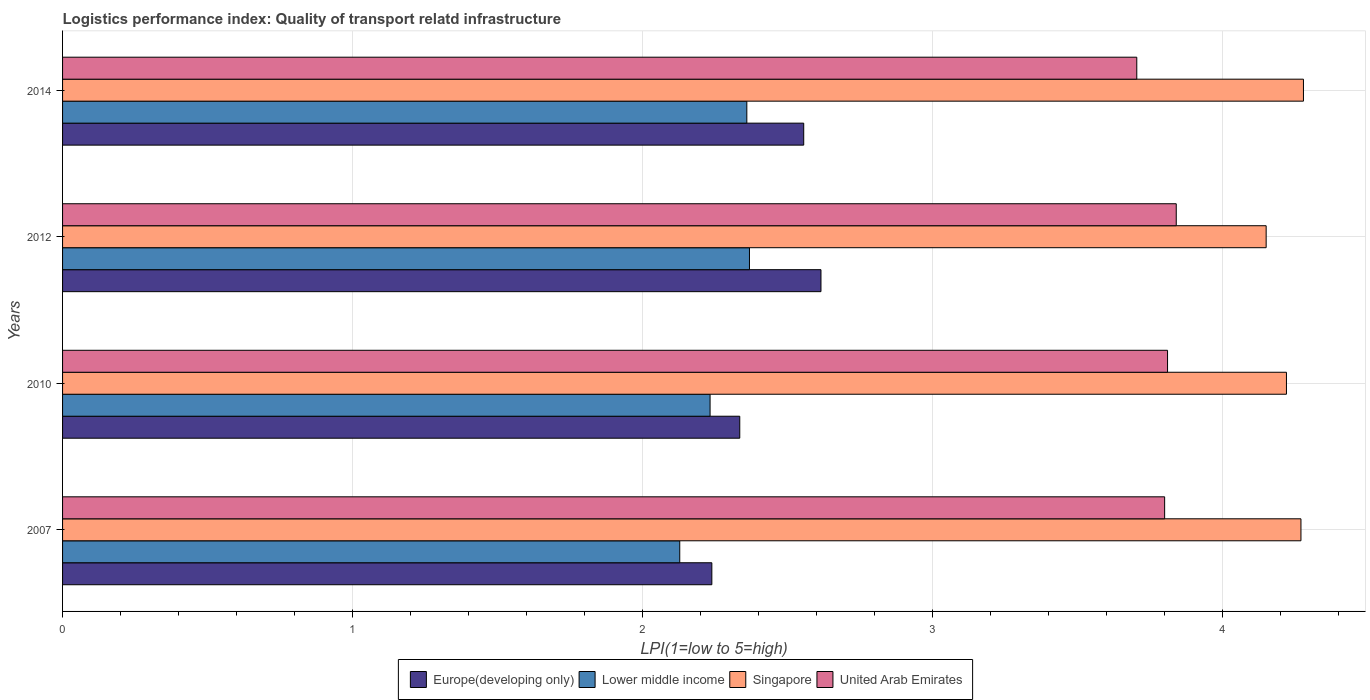How many different coloured bars are there?
Give a very brief answer. 4. How many groups of bars are there?
Keep it short and to the point. 4. Are the number of bars on each tick of the Y-axis equal?
Make the answer very short. Yes. How many bars are there on the 1st tick from the top?
Your answer should be very brief. 4. In how many cases, is the number of bars for a given year not equal to the number of legend labels?
Your answer should be very brief. 0. What is the logistics performance index in United Arab Emirates in 2014?
Your answer should be compact. 3.7. Across all years, what is the maximum logistics performance index in Lower middle income?
Ensure brevity in your answer.  2.37. Across all years, what is the minimum logistics performance index in Singapore?
Your answer should be very brief. 4.15. What is the total logistics performance index in Europe(developing only) in the graph?
Offer a very short reply. 9.74. What is the difference between the logistics performance index in United Arab Emirates in 2007 and that in 2014?
Your response must be concise. 0.1. What is the difference between the logistics performance index in Lower middle income in 2007 and the logistics performance index in Europe(developing only) in 2012?
Your answer should be very brief. -0.49. What is the average logistics performance index in Europe(developing only) per year?
Your response must be concise. 2.44. In the year 2007, what is the difference between the logistics performance index in Europe(developing only) and logistics performance index in Singapore?
Give a very brief answer. -2.03. In how many years, is the logistics performance index in United Arab Emirates greater than 4 ?
Provide a succinct answer. 0. What is the ratio of the logistics performance index in Lower middle income in 2007 to that in 2014?
Your response must be concise. 0.9. Is the logistics performance index in Lower middle income in 2010 less than that in 2014?
Your response must be concise. Yes. What is the difference between the highest and the second highest logistics performance index in Lower middle income?
Provide a succinct answer. 0.01. What is the difference between the highest and the lowest logistics performance index in Singapore?
Make the answer very short. 0.13. What does the 4th bar from the top in 2014 represents?
Your answer should be very brief. Europe(developing only). What does the 2nd bar from the bottom in 2014 represents?
Your answer should be very brief. Lower middle income. Is it the case that in every year, the sum of the logistics performance index in Europe(developing only) and logistics performance index in United Arab Emirates is greater than the logistics performance index in Lower middle income?
Give a very brief answer. Yes. Are all the bars in the graph horizontal?
Keep it short and to the point. Yes. What is the difference between two consecutive major ticks on the X-axis?
Offer a terse response. 1. Are the values on the major ticks of X-axis written in scientific E-notation?
Make the answer very short. No. Where does the legend appear in the graph?
Your answer should be compact. Bottom center. How many legend labels are there?
Your answer should be very brief. 4. What is the title of the graph?
Keep it short and to the point. Logistics performance index: Quality of transport relatd infrastructure. Does "Benin" appear as one of the legend labels in the graph?
Offer a terse response. No. What is the label or title of the X-axis?
Your answer should be very brief. LPI(1=low to 5=high). What is the label or title of the Y-axis?
Your answer should be very brief. Years. What is the LPI(1=low to 5=high) in Europe(developing only) in 2007?
Offer a very short reply. 2.24. What is the LPI(1=low to 5=high) of Lower middle income in 2007?
Offer a terse response. 2.13. What is the LPI(1=low to 5=high) in Singapore in 2007?
Offer a terse response. 4.27. What is the LPI(1=low to 5=high) in Europe(developing only) in 2010?
Offer a terse response. 2.33. What is the LPI(1=low to 5=high) of Lower middle income in 2010?
Offer a very short reply. 2.23. What is the LPI(1=low to 5=high) in Singapore in 2010?
Ensure brevity in your answer.  4.22. What is the LPI(1=low to 5=high) in United Arab Emirates in 2010?
Your answer should be very brief. 3.81. What is the LPI(1=low to 5=high) in Europe(developing only) in 2012?
Make the answer very short. 2.62. What is the LPI(1=low to 5=high) in Lower middle income in 2012?
Your response must be concise. 2.37. What is the LPI(1=low to 5=high) of Singapore in 2012?
Your answer should be very brief. 4.15. What is the LPI(1=low to 5=high) of United Arab Emirates in 2012?
Your answer should be compact. 3.84. What is the LPI(1=low to 5=high) in Europe(developing only) in 2014?
Ensure brevity in your answer.  2.56. What is the LPI(1=low to 5=high) of Lower middle income in 2014?
Offer a very short reply. 2.36. What is the LPI(1=low to 5=high) of Singapore in 2014?
Give a very brief answer. 4.28. What is the LPI(1=low to 5=high) of United Arab Emirates in 2014?
Ensure brevity in your answer.  3.7. Across all years, what is the maximum LPI(1=low to 5=high) of Europe(developing only)?
Your response must be concise. 2.62. Across all years, what is the maximum LPI(1=low to 5=high) in Lower middle income?
Your answer should be compact. 2.37. Across all years, what is the maximum LPI(1=low to 5=high) of Singapore?
Give a very brief answer. 4.28. Across all years, what is the maximum LPI(1=low to 5=high) of United Arab Emirates?
Give a very brief answer. 3.84. Across all years, what is the minimum LPI(1=low to 5=high) in Europe(developing only)?
Your answer should be very brief. 2.24. Across all years, what is the minimum LPI(1=low to 5=high) in Lower middle income?
Offer a terse response. 2.13. Across all years, what is the minimum LPI(1=low to 5=high) of Singapore?
Provide a succinct answer. 4.15. Across all years, what is the minimum LPI(1=low to 5=high) of United Arab Emirates?
Provide a short and direct response. 3.7. What is the total LPI(1=low to 5=high) of Europe(developing only) in the graph?
Your response must be concise. 9.74. What is the total LPI(1=low to 5=high) of Lower middle income in the graph?
Provide a short and direct response. 9.09. What is the total LPI(1=low to 5=high) of Singapore in the graph?
Keep it short and to the point. 16.92. What is the total LPI(1=low to 5=high) of United Arab Emirates in the graph?
Make the answer very short. 15.15. What is the difference between the LPI(1=low to 5=high) of Europe(developing only) in 2007 and that in 2010?
Offer a very short reply. -0.1. What is the difference between the LPI(1=low to 5=high) of Lower middle income in 2007 and that in 2010?
Your response must be concise. -0.1. What is the difference between the LPI(1=low to 5=high) in United Arab Emirates in 2007 and that in 2010?
Your answer should be compact. -0.01. What is the difference between the LPI(1=low to 5=high) in Europe(developing only) in 2007 and that in 2012?
Ensure brevity in your answer.  -0.38. What is the difference between the LPI(1=low to 5=high) in Lower middle income in 2007 and that in 2012?
Offer a very short reply. -0.24. What is the difference between the LPI(1=low to 5=high) in Singapore in 2007 and that in 2012?
Give a very brief answer. 0.12. What is the difference between the LPI(1=low to 5=high) of United Arab Emirates in 2007 and that in 2012?
Offer a terse response. -0.04. What is the difference between the LPI(1=low to 5=high) in Europe(developing only) in 2007 and that in 2014?
Make the answer very short. -0.32. What is the difference between the LPI(1=low to 5=high) in Lower middle income in 2007 and that in 2014?
Your answer should be compact. -0.23. What is the difference between the LPI(1=low to 5=high) of Singapore in 2007 and that in 2014?
Provide a short and direct response. -0.01. What is the difference between the LPI(1=low to 5=high) of United Arab Emirates in 2007 and that in 2014?
Your answer should be very brief. 0.1. What is the difference between the LPI(1=low to 5=high) of Europe(developing only) in 2010 and that in 2012?
Ensure brevity in your answer.  -0.28. What is the difference between the LPI(1=low to 5=high) of Lower middle income in 2010 and that in 2012?
Make the answer very short. -0.14. What is the difference between the LPI(1=low to 5=high) in Singapore in 2010 and that in 2012?
Your answer should be very brief. 0.07. What is the difference between the LPI(1=low to 5=high) of United Arab Emirates in 2010 and that in 2012?
Give a very brief answer. -0.03. What is the difference between the LPI(1=low to 5=high) of Europe(developing only) in 2010 and that in 2014?
Your answer should be compact. -0.22. What is the difference between the LPI(1=low to 5=high) in Lower middle income in 2010 and that in 2014?
Offer a very short reply. -0.13. What is the difference between the LPI(1=low to 5=high) in Singapore in 2010 and that in 2014?
Provide a succinct answer. -0.06. What is the difference between the LPI(1=low to 5=high) in United Arab Emirates in 2010 and that in 2014?
Keep it short and to the point. 0.11. What is the difference between the LPI(1=low to 5=high) in Europe(developing only) in 2012 and that in 2014?
Provide a short and direct response. 0.06. What is the difference between the LPI(1=low to 5=high) of Lower middle income in 2012 and that in 2014?
Offer a terse response. 0.01. What is the difference between the LPI(1=low to 5=high) in Singapore in 2012 and that in 2014?
Your answer should be compact. -0.13. What is the difference between the LPI(1=low to 5=high) of United Arab Emirates in 2012 and that in 2014?
Your response must be concise. 0.14. What is the difference between the LPI(1=low to 5=high) of Europe(developing only) in 2007 and the LPI(1=low to 5=high) of Lower middle income in 2010?
Offer a terse response. 0.01. What is the difference between the LPI(1=low to 5=high) of Europe(developing only) in 2007 and the LPI(1=low to 5=high) of Singapore in 2010?
Your response must be concise. -1.98. What is the difference between the LPI(1=low to 5=high) in Europe(developing only) in 2007 and the LPI(1=low to 5=high) in United Arab Emirates in 2010?
Your response must be concise. -1.57. What is the difference between the LPI(1=low to 5=high) of Lower middle income in 2007 and the LPI(1=low to 5=high) of Singapore in 2010?
Keep it short and to the point. -2.09. What is the difference between the LPI(1=low to 5=high) of Lower middle income in 2007 and the LPI(1=low to 5=high) of United Arab Emirates in 2010?
Ensure brevity in your answer.  -1.68. What is the difference between the LPI(1=low to 5=high) of Singapore in 2007 and the LPI(1=low to 5=high) of United Arab Emirates in 2010?
Provide a short and direct response. 0.46. What is the difference between the LPI(1=low to 5=high) of Europe(developing only) in 2007 and the LPI(1=low to 5=high) of Lower middle income in 2012?
Keep it short and to the point. -0.13. What is the difference between the LPI(1=low to 5=high) in Europe(developing only) in 2007 and the LPI(1=low to 5=high) in Singapore in 2012?
Give a very brief answer. -1.91. What is the difference between the LPI(1=low to 5=high) in Europe(developing only) in 2007 and the LPI(1=low to 5=high) in United Arab Emirates in 2012?
Give a very brief answer. -1.6. What is the difference between the LPI(1=low to 5=high) of Lower middle income in 2007 and the LPI(1=low to 5=high) of Singapore in 2012?
Provide a succinct answer. -2.02. What is the difference between the LPI(1=low to 5=high) in Lower middle income in 2007 and the LPI(1=low to 5=high) in United Arab Emirates in 2012?
Ensure brevity in your answer.  -1.71. What is the difference between the LPI(1=low to 5=high) in Singapore in 2007 and the LPI(1=low to 5=high) in United Arab Emirates in 2012?
Give a very brief answer. 0.43. What is the difference between the LPI(1=low to 5=high) of Europe(developing only) in 2007 and the LPI(1=low to 5=high) of Lower middle income in 2014?
Your answer should be compact. -0.12. What is the difference between the LPI(1=low to 5=high) in Europe(developing only) in 2007 and the LPI(1=low to 5=high) in Singapore in 2014?
Offer a terse response. -2.04. What is the difference between the LPI(1=low to 5=high) in Europe(developing only) in 2007 and the LPI(1=low to 5=high) in United Arab Emirates in 2014?
Provide a short and direct response. -1.47. What is the difference between the LPI(1=low to 5=high) in Lower middle income in 2007 and the LPI(1=low to 5=high) in Singapore in 2014?
Make the answer very short. -2.15. What is the difference between the LPI(1=low to 5=high) of Lower middle income in 2007 and the LPI(1=low to 5=high) of United Arab Emirates in 2014?
Provide a succinct answer. -1.58. What is the difference between the LPI(1=low to 5=high) of Singapore in 2007 and the LPI(1=low to 5=high) of United Arab Emirates in 2014?
Offer a very short reply. 0.57. What is the difference between the LPI(1=low to 5=high) in Europe(developing only) in 2010 and the LPI(1=low to 5=high) in Lower middle income in 2012?
Provide a succinct answer. -0.03. What is the difference between the LPI(1=low to 5=high) of Europe(developing only) in 2010 and the LPI(1=low to 5=high) of Singapore in 2012?
Your answer should be compact. -1.81. What is the difference between the LPI(1=low to 5=high) in Europe(developing only) in 2010 and the LPI(1=low to 5=high) in United Arab Emirates in 2012?
Provide a succinct answer. -1.5. What is the difference between the LPI(1=low to 5=high) in Lower middle income in 2010 and the LPI(1=low to 5=high) in Singapore in 2012?
Offer a very short reply. -1.92. What is the difference between the LPI(1=low to 5=high) in Lower middle income in 2010 and the LPI(1=low to 5=high) in United Arab Emirates in 2012?
Your response must be concise. -1.61. What is the difference between the LPI(1=low to 5=high) of Singapore in 2010 and the LPI(1=low to 5=high) of United Arab Emirates in 2012?
Keep it short and to the point. 0.38. What is the difference between the LPI(1=low to 5=high) in Europe(developing only) in 2010 and the LPI(1=low to 5=high) in Lower middle income in 2014?
Offer a terse response. -0.02. What is the difference between the LPI(1=low to 5=high) in Europe(developing only) in 2010 and the LPI(1=low to 5=high) in Singapore in 2014?
Keep it short and to the point. -1.94. What is the difference between the LPI(1=low to 5=high) of Europe(developing only) in 2010 and the LPI(1=low to 5=high) of United Arab Emirates in 2014?
Make the answer very short. -1.37. What is the difference between the LPI(1=low to 5=high) of Lower middle income in 2010 and the LPI(1=low to 5=high) of Singapore in 2014?
Give a very brief answer. -2.05. What is the difference between the LPI(1=low to 5=high) of Lower middle income in 2010 and the LPI(1=low to 5=high) of United Arab Emirates in 2014?
Your response must be concise. -1.47. What is the difference between the LPI(1=low to 5=high) of Singapore in 2010 and the LPI(1=low to 5=high) of United Arab Emirates in 2014?
Give a very brief answer. 0.52. What is the difference between the LPI(1=low to 5=high) of Europe(developing only) in 2012 and the LPI(1=low to 5=high) of Lower middle income in 2014?
Your answer should be very brief. 0.26. What is the difference between the LPI(1=low to 5=high) in Europe(developing only) in 2012 and the LPI(1=low to 5=high) in Singapore in 2014?
Offer a very short reply. -1.66. What is the difference between the LPI(1=low to 5=high) of Europe(developing only) in 2012 and the LPI(1=low to 5=high) of United Arab Emirates in 2014?
Provide a short and direct response. -1.09. What is the difference between the LPI(1=low to 5=high) of Lower middle income in 2012 and the LPI(1=low to 5=high) of Singapore in 2014?
Provide a succinct answer. -1.91. What is the difference between the LPI(1=low to 5=high) of Lower middle income in 2012 and the LPI(1=low to 5=high) of United Arab Emirates in 2014?
Your answer should be very brief. -1.34. What is the difference between the LPI(1=low to 5=high) in Singapore in 2012 and the LPI(1=low to 5=high) in United Arab Emirates in 2014?
Provide a short and direct response. 0.45. What is the average LPI(1=low to 5=high) in Europe(developing only) per year?
Provide a short and direct response. 2.44. What is the average LPI(1=low to 5=high) in Lower middle income per year?
Ensure brevity in your answer.  2.27. What is the average LPI(1=low to 5=high) of Singapore per year?
Your answer should be very brief. 4.23. What is the average LPI(1=low to 5=high) of United Arab Emirates per year?
Your answer should be very brief. 3.79. In the year 2007, what is the difference between the LPI(1=low to 5=high) of Europe(developing only) and LPI(1=low to 5=high) of Lower middle income?
Provide a succinct answer. 0.11. In the year 2007, what is the difference between the LPI(1=low to 5=high) of Europe(developing only) and LPI(1=low to 5=high) of Singapore?
Offer a terse response. -2.03. In the year 2007, what is the difference between the LPI(1=low to 5=high) in Europe(developing only) and LPI(1=low to 5=high) in United Arab Emirates?
Your response must be concise. -1.56. In the year 2007, what is the difference between the LPI(1=low to 5=high) of Lower middle income and LPI(1=low to 5=high) of Singapore?
Provide a succinct answer. -2.14. In the year 2007, what is the difference between the LPI(1=low to 5=high) in Lower middle income and LPI(1=low to 5=high) in United Arab Emirates?
Provide a succinct answer. -1.67. In the year 2007, what is the difference between the LPI(1=low to 5=high) in Singapore and LPI(1=low to 5=high) in United Arab Emirates?
Make the answer very short. 0.47. In the year 2010, what is the difference between the LPI(1=low to 5=high) of Europe(developing only) and LPI(1=low to 5=high) of Lower middle income?
Make the answer very short. 0.1. In the year 2010, what is the difference between the LPI(1=low to 5=high) in Europe(developing only) and LPI(1=low to 5=high) in Singapore?
Offer a terse response. -1.89. In the year 2010, what is the difference between the LPI(1=low to 5=high) in Europe(developing only) and LPI(1=low to 5=high) in United Arab Emirates?
Keep it short and to the point. -1.48. In the year 2010, what is the difference between the LPI(1=low to 5=high) in Lower middle income and LPI(1=low to 5=high) in Singapore?
Offer a very short reply. -1.99. In the year 2010, what is the difference between the LPI(1=low to 5=high) in Lower middle income and LPI(1=low to 5=high) in United Arab Emirates?
Keep it short and to the point. -1.58. In the year 2010, what is the difference between the LPI(1=low to 5=high) in Singapore and LPI(1=low to 5=high) in United Arab Emirates?
Offer a very short reply. 0.41. In the year 2012, what is the difference between the LPI(1=low to 5=high) of Europe(developing only) and LPI(1=low to 5=high) of Lower middle income?
Provide a short and direct response. 0.25. In the year 2012, what is the difference between the LPI(1=low to 5=high) in Europe(developing only) and LPI(1=low to 5=high) in Singapore?
Offer a terse response. -1.53. In the year 2012, what is the difference between the LPI(1=low to 5=high) in Europe(developing only) and LPI(1=low to 5=high) in United Arab Emirates?
Keep it short and to the point. -1.23. In the year 2012, what is the difference between the LPI(1=low to 5=high) of Lower middle income and LPI(1=low to 5=high) of Singapore?
Provide a short and direct response. -1.78. In the year 2012, what is the difference between the LPI(1=low to 5=high) in Lower middle income and LPI(1=low to 5=high) in United Arab Emirates?
Provide a short and direct response. -1.47. In the year 2012, what is the difference between the LPI(1=low to 5=high) of Singapore and LPI(1=low to 5=high) of United Arab Emirates?
Provide a succinct answer. 0.31. In the year 2014, what is the difference between the LPI(1=low to 5=high) of Europe(developing only) and LPI(1=low to 5=high) of Lower middle income?
Give a very brief answer. 0.2. In the year 2014, what is the difference between the LPI(1=low to 5=high) of Europe(developing only) and LPI(1=low to 5=high) of Singapore?
Give a very brief answer. -1.72. In the year 2014, what is the difference between the LPI(1=low to 5=high) in Europe(developing only) and LPI(1=low to 5=high) in United Arab Emirates?
Give a very brief answer. -1.15. In the year 2014, what is the difference between the LPI(1=low to 5=high) in Lower middle income and LPI(1=low to 5=high) in Singapore?
Offer a very short reply. -1.92. In the year 2014, what is the difference between the LPI(1=low to 5=high) of Lower middle income and LPI(1=low to 5=high) of United Arab Emirates?
Make the answer very short. -1.34. In the year 2014, what is the difference between the LPI(1=low to 5=high) in Singapore and LPI(1=low to 5=high) in United Arab Emirates?
Ensure brevity in your answer.  0.57. What is the ratio of the LPI(1=low to 5=high) of Europe(developing only) in 2007 to that in 2010?
Provide a short and direct response. 0.96. What is the ratio of the LPI(1=low to 5=high) in Lower middle income in 2007 to that in 2010?
Make the answer very short. 0.95. What is the ratio of the LPI(1=low to 5=high) in Singapore in 2007 to that in 2010?
Your answer should be very brief. 1.01. What is the ratio of the LPI(1=low to 5=high) in United Arab Emirates in 2007 to that in 2010?
Your answer should be compact. 1. What is the ratio of the LPI(1=low to 5=high) in Europe(developing only) in 2007 to that in 2012?
Give a very brief answer. 0.86. What is the ratio of the LPI(1=low to 5=high) in Lower middle income in 2007 to that in 2012?
Provide a succinct answer. 0.9. What is the ratio of the LPI(1=low to 5=high) of Singapore in 2007 to that in 2012?
Provide a short and direct response. 1.03. What is the ratio of the LPI(1=low to 5=high) of United Arab Emirates in 2007 to that in 2012?
Keep it short and to the point. 0.99. What is the ratio of the LPI(1=low to 5=high) of Europe(developing only) in 2007 to that in 2014?
Offer a terse response. 0.88. What is the ratio of the LPI(1=low to 5=high) in Lower middle income in 2007 to that in 2014?
Keep it short and to the point. 0.9. What is the ratio of the LPI(1=low to 5=high) in United Arab Emirates in 2007 to that in 2014?
Offer a terse response. 1.03. What is the ratio of the LPI(1=low to 5=high) in Europe(developing only) in 2010 to that in 2012?
Ensure brevity in your answer.  0.89. What is the ratio of the LPI(1=low to 5=high) in Lower middle income in 2010 to that in 2012?
Offer a terse response. 0.94. What is the ratio of the LPI(1=low to 5=high) of Singapore in 2010 to that in 2012?
Ensure brevity in your answer.  1.02. What is the ratio of the LPI(1=low to 5=high) of United Arab Emirates in 2010 to that in 2012?
Your answer should be compact. 0.99. What is the ratio of the LPI(1=low to 5=high) of Europe(developing only) in 2010 to that in 2014?
Ensure brevity in your answer.  0.91. What is the ratio of the LPI(1=low to 5=high) in Lower middle income in 2010 to that in 2014?
Make the answer very short. 0.95. What is the ratio of the LPI(1=low to 5=high) of Singapore in 2010 to that in 2014?
Make the answer very short. 0.99. What is the ratio of the LPI(1=low to 5=high) in United Arab Emirates in 2010 to that in 2014?
Your response must be concise. 1.03. What is the ratio of the LPI(1=low to 5=high) in Europe(developing only) in 2012 to that in 2014?
Provide a short and direct response. 1.02. What is the ratio of the LPI(1=low to 5=high) in Singapore in 2012 to that in 2014?
Give a very brief answer. 0.97. What is the ratio of the LPI(1=low to 5=high) in United Arab Emirates in 2012 to that in 2014?
Provide a short and direct response. 1.04. What is the difference between the highest and the second highest LPI(1=low to 5=high) of Europe(developing only)?
Keep it short and to the point. 0.06. What is the difference between the highest and the second highest LPI(1=low to 5=high) in Lower middle income?
Your answer should be compact. 0.01. What is the difference between the highest and the second highest LPI(1=low to 5=high) of Singapore?
Provide a short and direct response. 0.01. What is the difference between the highest and the lowest LPI(1=low to 5=high) in Europe(developing only)?
Your answer should be very brief. 0.38. What is the difference between the highest and the lowest LPI(1=low to 5=high) of Lower middle income?
Your answer should be very brief. 0.24. What is the difference between the highest and the lowest LPI(1=low to 5=high) in Singapore?
Your answer should be very brief. 0.13. What is the difference between the highest and the lowest LPI(1=low to 5=high) in United Arab Emirates?
Your answer should be very brief. 0.14. 